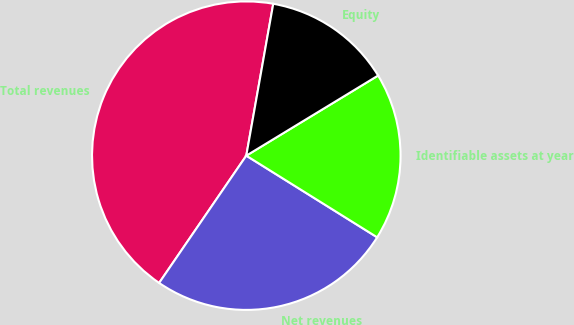<chart> <loc_0><loc_0><loc_500><loc_500><pie_chart><fcel>Total revenues<fcel>Net revenues<fcel>Identifiable assets at year<fcel>Equity<nl><fcel>43.24%<fcel>25.68%<fcel>17.57%<fcel>13.51%<nl></chart> 